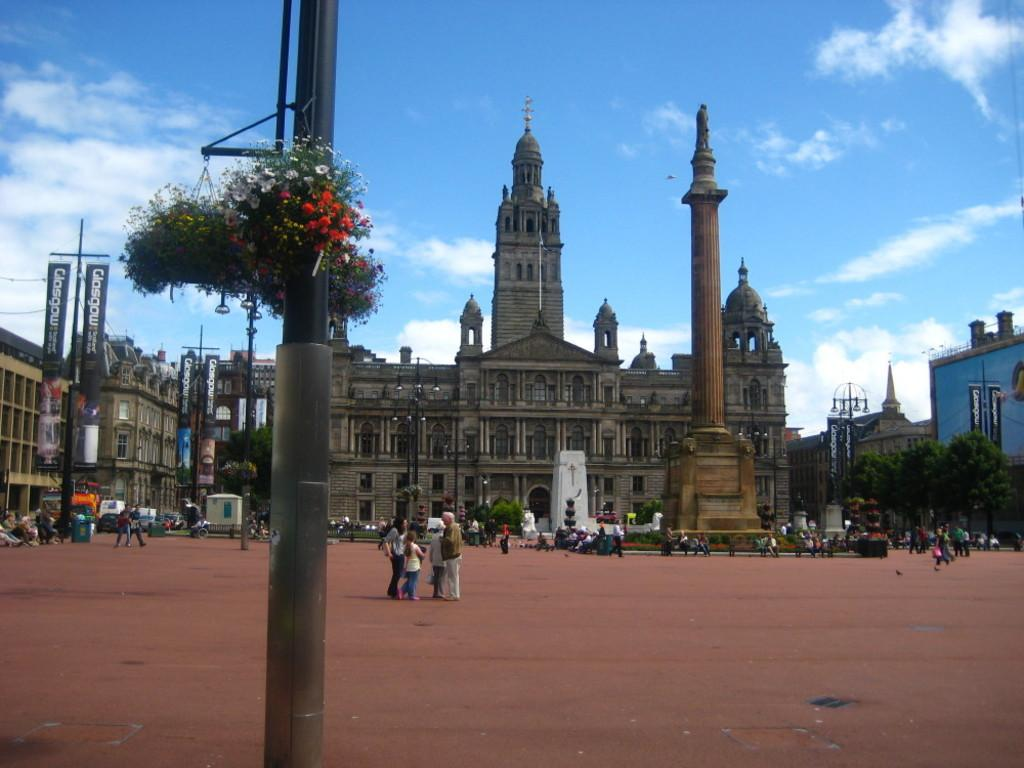What type of plants are on poles in the image? There are plants with flowers on poles in the image. What can be seen in the background of the image? There are people, buildings, trees, a sculpture on a tower, a banner, and lights on poles in the background of the image. What is visible in the sky in the image? The sky is visible in the background of the image. What type of bottle is being used to care for the plants in the image? There is no bottle present in the image; the plants are on poles with flowers. 